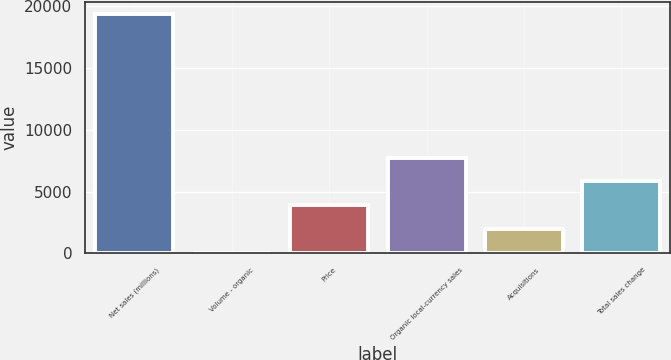Convert chart. <chart><loc_0><loc_0><loc_500><loc_500><bar_chart><fcel>Net sales (millions)<fcel>Volume - organic<fcel>Price<fcel>Organic local-currency sales<fcel>Acquisitions<fcel>Total sales change<nl><fcel>19376<fcel>0.8<fcel>3875.84<fcel>7750.88<fcel>1938.32<fcel>5813.36<nl></chart> 